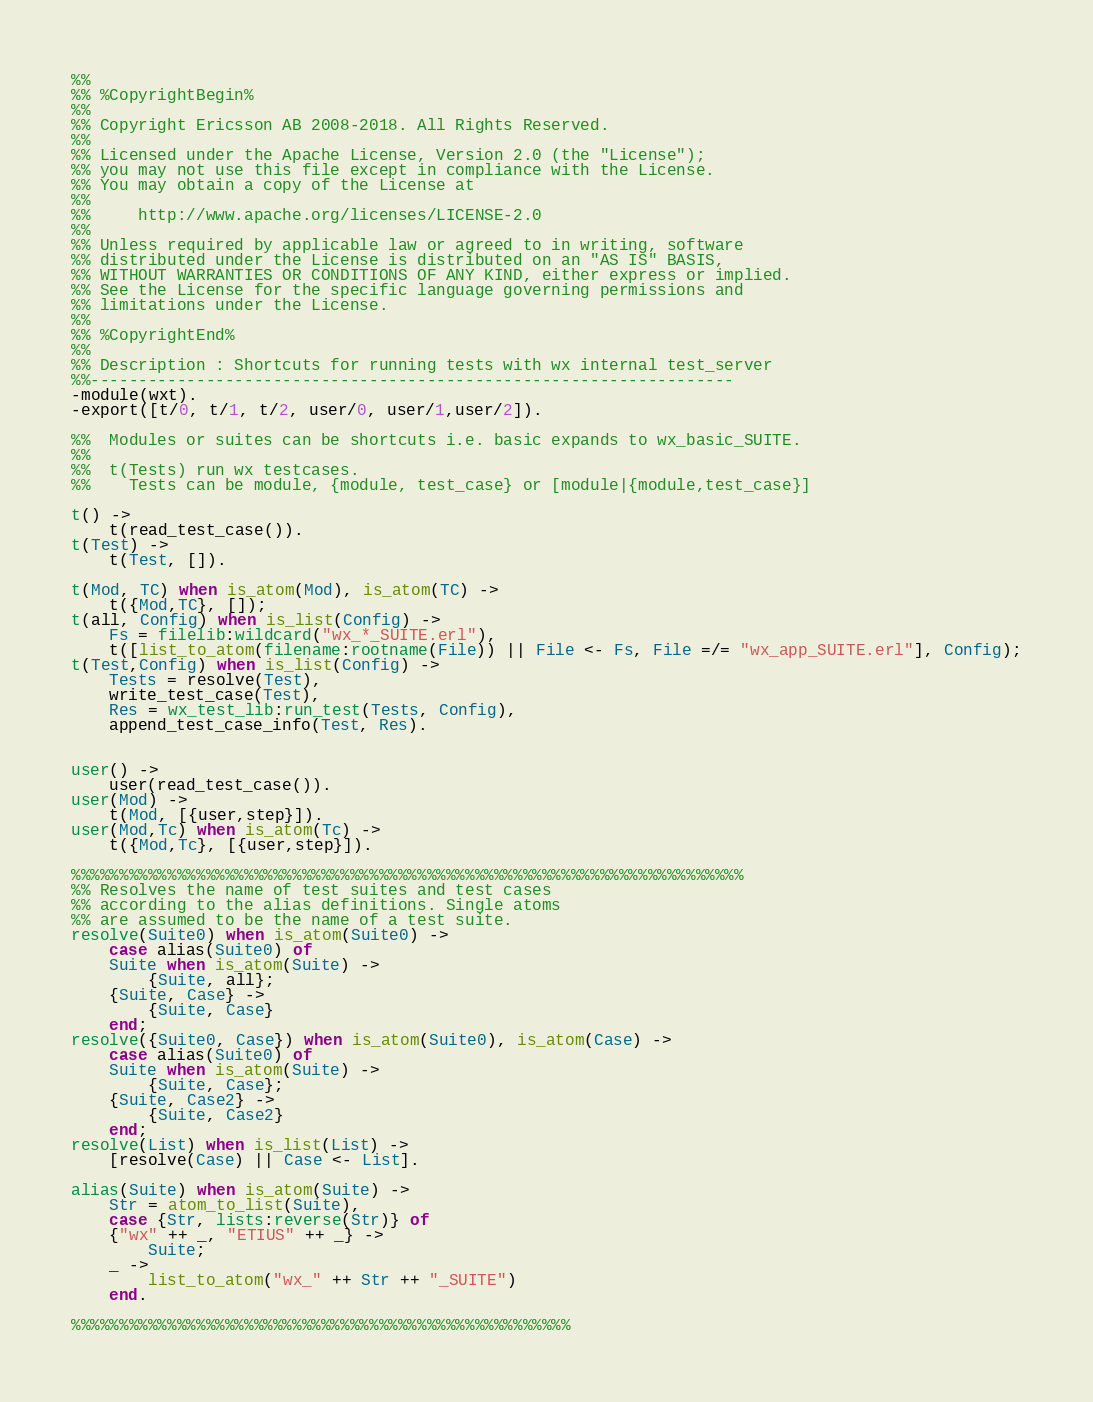Convert code to text. <code><loc_0><loc_0><loc_500><loc_500><_Erlang_>%%
%% %CopyrightBegin%
%%
%% Copyright Ericsson AB 2008-2018. All Rights Reserved.
%%
%% Licensed under the Apache License, Version 2.0 (the "License");
%% you may not use this file except in compliance with the License.
%% You may obtain a copy of the License at
%%
%%     http://www.apache.org/licenses/LICENSE-2.0
%%
%% Unless required by applicable law or agreed to in writing, software
%% distributed under the License is distributed on an "AS IS" BASIS,
%% WITHOUT WARRANTIES OR CONDITIONS OF ANY KIND, either express or implied.
%% See the License for the specific language governing permissions and
%% limitations under the License.
%%
%% %CopyrightEnd%
%%
%% Description : Shortcuts for running tests with wx internal test_server
%%-------------------------------------------------------------------
-module(wxt).
-export([t/0, t/1, t/2, user/0, user/1,user/2]).

%%  Modules or suites can be shortcuts i.e. basic expands to wx_basic_SUITE.
%%  
%%  t(Tests) run wx testcases.
%%    Tests can be module, {module, test_case} or [module|{module,test_case}]

t() ->
    t(read_test_case()).
t(Test) ->
    t(Test, []).

t(Mod, TC) when is_atom(Mod), is_atom(TC) ->
    t({Mod,TC}, []);
t(all, Config) when is_list(Config) ->
    Fs = filelib:wildcard("wx_*_SUITE.erl"),
    t([list_to_atom(filename:rootname(File)) || File <- Fs, File =/= "wx_app_SUITE.erl"], Config);
t(Test,Config) when is_list(Config) ->
    Tests = resolve(Test),
    write_test_case(Test),
    Res = wx_test_lib:run_test(Tests, Config),    
    append_test_case_info(Test, Res).


user() ->
    user(read_test_case()). 
user(Mod) ->
    t(Mod, [{user,step}]).
user(Mod,Tc) when is_atom(Tc) ->
    t({Mod,Tc}, [{user,step}]).
    
%%%%%%%%%%%%%%%%%%%%%%%%%%%%%%%%%%%%%%%%%%%%%%%%%%%%%%%%%%%%%%%%%%%%%%
%% Resolves the name of test suites and test cases
%% according to the alias definitions. Single atoms
%% are assumed to be the name of a test suite. 
resolve(Suite0) when is_atom(Suite0) ->
    case alias(Suite0) of
	Suite when is_atom(Suite) ->
	    {Suite, all};
	{Suite, Case} ->
	    {Suite, Case}
    end;
resolve({Suite0, Case}) when is_atom(Suite0), is_atom(Case) ->
    case alias(Suite0) of
	Suite when is_atom(Suite) ->
	    {Suite, Case};
	{Suite, Case2} ->
	    {Suite, Case2}
    end;
resolve(List) when is_list(List) ->
    [resolve(Case) || Case <- List].

alias(Suite) when is_atom(Suite) ->
    Str = atom_to_list(Suite),
    case {Str, lists:reverse(Str)} of
	{"wx" ++ _, "ETIUS" ++ _} ->
	    Suite;
	_ -> 
	    list_to_atom("wx_" ++ Str ++ "_SUITE")
    end.

%%%%%%%%%%%%%%%%%%%%%%%%%%%%%%%%%%%%%%%%%%%%%%%%%%%%
</code> 